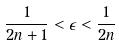<formula> <loc_0><loc_0><loc_500><loc_500>\frac { 1 } { 2 n + 1 } < \epsilon < \frac { 1 } { 2 n }</formula> 